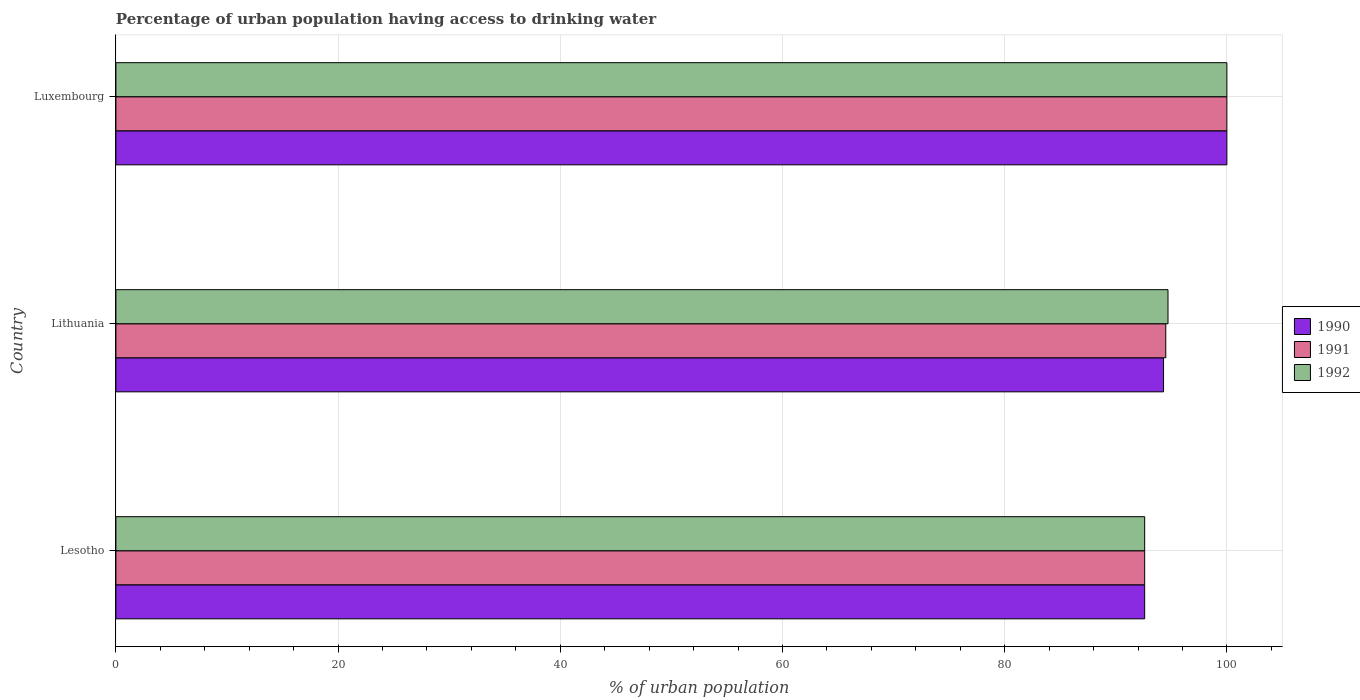How many groups of bars are there?
Give a very brief answer. 3. Are the number of bars per tick equal to the number of legend labels?
Your answer should be compact. Yes. Are the number of bars on each tick of the Y-axis equal?
Provide a short and direct response. Yes. How many bars are there on the 1st tick from the top?
Your response must be concise. 3. How many bars are there on the 3rd tick from the bottom?
Offer a terse response. 3. What is the label of the 2nd group of bars from the top?
Give a very brief answer. Lithuania. What is the percentage of urban population having access to drinking water in 1992 in Lesotho?
Your answer should be compact. 92.6. Across all countries, what is the minimum percentage of urban population having access to drinking water in 1991?
Your response must be concise. 92.6. In which country was the percentage of urban population having access to drinking water in 1991 maximum?
Your answer should be very brief. Luxembourg. In which country was the percentage of urban population having access to drinking water in 1990 minimum?
Your answer should be very brief. Lesotho. What is the total percentage of urban population having access to drinking water in 1992 in the graph?
Your answer should be very brief. 287.3. What is the difference between the percentage of urban population having access to drinking water in 1992 in Lithuania and that in Luxembourg?
Give a very brief answer. -5.3. What is the difference between the percentage of urban population having access to drinking water in 1990 in Lesotho and the percentage of urban population having access to drinking water in 1991 in Lithuania?
Offer a terse response. -1.9. What is the average percentage of urban population having access to drinking water in 1991 per country?
Keep it short and to the point. 95.7. What is the difference between the percentage of urban population having access to drinking water in 1990 and percentage of urban population having access to drinking water in 1992 in Lesotho?
Your answer should be compact. 0. In how many countries, is the percentage of urban population having access to drinking water in 1990 greater than 8 %?
Offer a terse response. 3. What is the ratio of the percentage of urban population having access to drinking water in 1991 in Lithuania to that in Luxembourg?
Your answer should be compact. 0.94. What is the difference between the highest and the second highest percentage of urban population having access to drinking water in 1991?
Give a very brief answer. 5.5. What is the difference between the highest and the lowest percentage of urban population having access to drinking water in 1991?
Give a very brief answer. 7.4. What does the 3rd bar from the top in Lesotho represents?
Provide a short and direct response. 1990. Is it the case that in every country, the sum of the percentage of urban population having access to drinking water in 1990 and percentage of urban population having access to drinking water in 1992 is greater than the percentage of urban population having access to drinking water in 1991?
Make the answer very short. Yes. Are all the bars in the graph horizontal?
Provide a succinct answer. Yes. Are the values on the major ticks of X-axis written in scientific E-notation?
Provide a short and direct response. No. Does the graph contain any zero values?
Your answer should be compact. No. Does the graph contain grids?
Your answer should be compact. Yes. Where does the legend appear in the graph?
Ensure brevity in your answer.  Center right. What is the title of the graph?
Your answer should be very brief. Percentage of urban population having access to drinking water. Does "2009" appear as one of the legend labels in the graph?
Provide a succinct answer. No. What is the label or title of the X-axis?
Make the answer very short. % of urban population. What is the label or title of the Y-axis?
Offer a terse response. Country. What is the % of urban population of 1990 in Lesotho?
Give a very brief answer. 92.6. What is the % of urban population of 1991 in Lesotho?
Give a very brief answer. 92.6. What is the % of urban population of 1992 in Lesotho?
Ensure brevity in your answer.  92.6. What is the % of urban population of 1990 in Lithuania?
Give a very brief answer. 94.3. What is the % of urban population in 1991 in Lithuania?
Ensure brevity in your answer.  94.5. What is the % of urban population of 1992 in Lithuania?
Keep it short and to the point. 94.7. What is the % of urban population of 1992 in Luxembourg?
Offer a very short reply. 100. Across all countries, what is the maximum % of urban population of 1990?
Your answer should be compact. 100. Across all countries, what is the maximum % of urban population in 1991?
Keep it short and to the point. 100. Across all countries, what is the maximum % of urban population in 1992?
Your response must be concise. 100. Across all countries, what is the minimum % of urban population of 1990?
Ensure brevity in your answer.  92.6. Across all countries, what is the minimum % of urban population in 1991?
Offer a very short reply. 92.6. Across all countries, what is the minimum % of urban population in 1992?
Make the answer very short. 92.6. What is the total % of urban population of 1990 in the graph?
Your response must be concise. 286.9. What is the total % of urban population of 1991 in the graph?
Offer a very short reply. 287.1. What is the total % of urban population of 1992 in the graph?
Offer a very short reply. 287.3. What is the difference between the % of urban population of 1992 in Lesotho and that in Lithuania?
Your response must be concise. -2.1. What is the difference between the % of urban population of 1990 in Lesotho and that in Luxembourg?
Offer a very short reply. -7.4. What is the difference between the % of urban population in 1992 in Lesotho and that in Luxembourg?
Give a very brief answer. -7.4. What is the difference between the % of urban population in 1990 in Lithuania and that in Luxembourg?
Give a very brief answer. -5.7. What is the difference between the % of urban population in 1992 in Lithuania and that in Luxembourg?
Offer a terse response. -5.3. What is the difference between the % of urban population of 1990 in Lesotho and the % of urban population of 1991 in Lithuania?
Make the answer very short. -1.9. What is the average % of urban population in 1990 per country?
Provide a succinct answer. 95.63. What is the average % of urban population in 1991 per country?
Offer a terse response. 95.7. What is the average % of urban population in 1992 per country?
Your answer should be very brief. 95.77. What is the difference between the % of urban population of 1990 and % of urban population of 1991 in Lesotho?
Your response must be concise. 0. What is the difference between the % of urban population in 1990 and % of urban population in 1992 in Lesotho?
Provide a short and direct response. 0. What is the difference between the % of urban population of 1991 and % of urban population of 1992 in Lesotho?
Make the answer very short. 0. What is the difference between the % of urban population of 1990 and % of urban population of 1991 in Lithuania?
Provide a short and direct response. -0.2. What is the difference between the % of urban population of 1991 and % of urban population of 1992 in Lithuania?
Keep it short and to the point. -0.2. What is the difference between the % of urban population of 1990 and % of urban population of 1991 in Luxembourg?
Provide a short and direct response. 0. What is the difference between the % of urban population in 1991 and % of urban population in 1992 in Luxembourg?
Keep it short and to the point. 0. What is the ratio of the % of urban population of 1990 in Lesotho to that in Lithuania?
Make the answer very short. 0.98. What is the ratio of the % of urban population in 1991 in Lesotho to that in Lithuania?
Offer a terse response. 0.98. What is the ratio of the % of urban population in 1992 in Lesotho to that in Lithuania?
Offer a very short reply. 0.98. What is the ratio of the % of urban population in 1990 in Lesotho to that in Luxembourg?
Provide a short and direct response. 0.93. What is the ratio of the % of urban population of 1991 in Lesotho to that in Luxembourg?
Give a very brief answer. 0.93. What is the ratio of the % of urban population in 1992 in Lesotho to that in Luxembourg?
Give a very brief answer. 0.93. What is the ratio of the % of urban population in 1990 in Lithuania to that in Luxembourg?
Provide a succinct answer. 0.94. What is the ratio of the % of urban population in 1991 in Lithuania to that in Luxembourg?
Provide a succinct answer. 0.94. What is the ratio of the % of urban population of 1992 in Lithuania to that in Luxembourg?
Your answer should be very brief. 0.95. What is the difference between the highest and the second highest % of urban population of 1990?
Offer a very short reply. 5.7. What is the difference between the highest and the lowest % of urban population in 1990?
Your answer should be very brief. 7.4. 